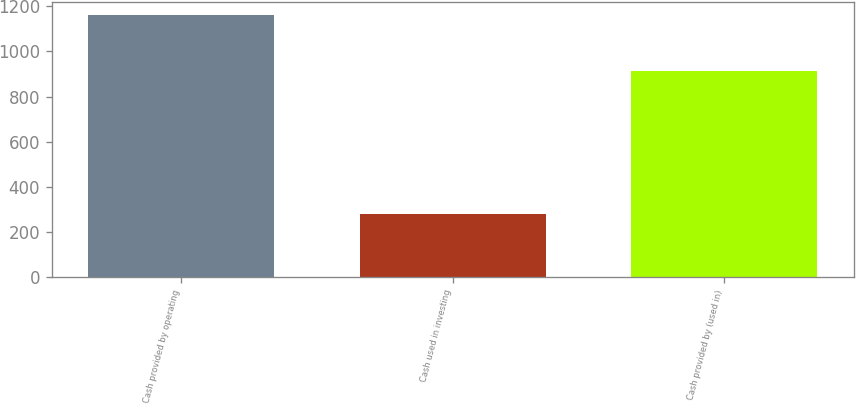Convert chart to OTSL. <chart><loc_0><loc_0><loc_500><loc_500><bar_chart><fcel>Cash provided by operating<fcel>Cash used in investing<fcel>Cash provided by (used in)<nl><fcel>1163<fcel>281<fcel>913<nl></chart> 